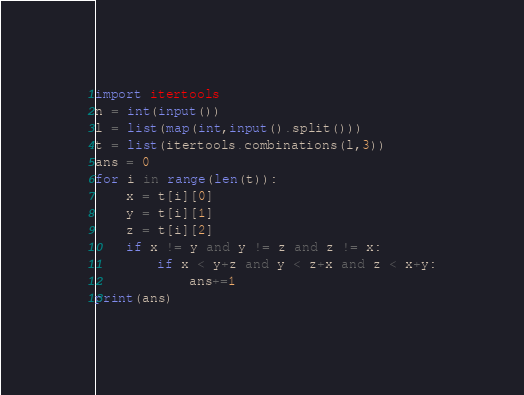Convert code to text. <code><loc_0><loc_0><loc_500><loc_500><_Python_>import itertools
n = int(input())
l = list(map(int,input().split()))
t = list(itertools.combinations(l,3))
ans = 0
for i in range(len(t)):
    x = t[i][0]
    y = t[i][1]
    z = t[i][2]
    if x != y and y != z and z != x:
        if x < y+z and y < z+x and z < x+y:
            ans+=1
print(ans)</code> 